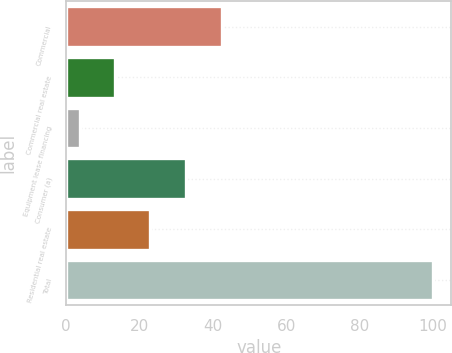Convert chart to OTSL. <chart><loc_0><loc_0><loc_500><loc_500><bar_chart><fcel>Commercial<fcel>Commercial real estate<fcel>Equipment lease financing<fcel>Consumer (a)<fcel>Residential real estate<fcel>Total<nl><fcel>42.4<fcel>13.33<fcel>3.7<fcel>32.59<fcel>22.96<fcel>100<nl></chart> 